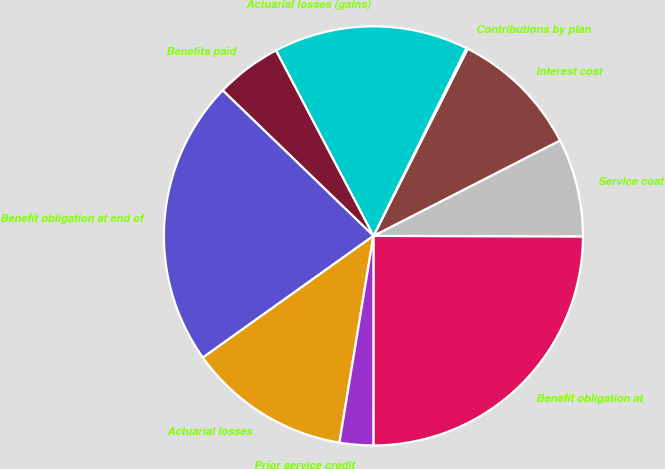<chart> <loc_0><loc_0><loc_500><loc_500><pie_chart><fcel>Benefit obligation at<fcel>Service cost<fcel>Interest cost<fcel>Contributions by plan<fcel>Actuarial losses (gains)<fcel>Benefits paid<fcel>Benefit obligation at end of<fcel>Actuarial losses<fcel>Prior service credit<nl><fcel>24.97%<fcel>7.56%<fcel>10.05%<fcel>0.11%<fcel>15.02%<fcel>5.08%<fcel>22.08%<fcel>12.54%<fcel>2.59%<nl></chart> 